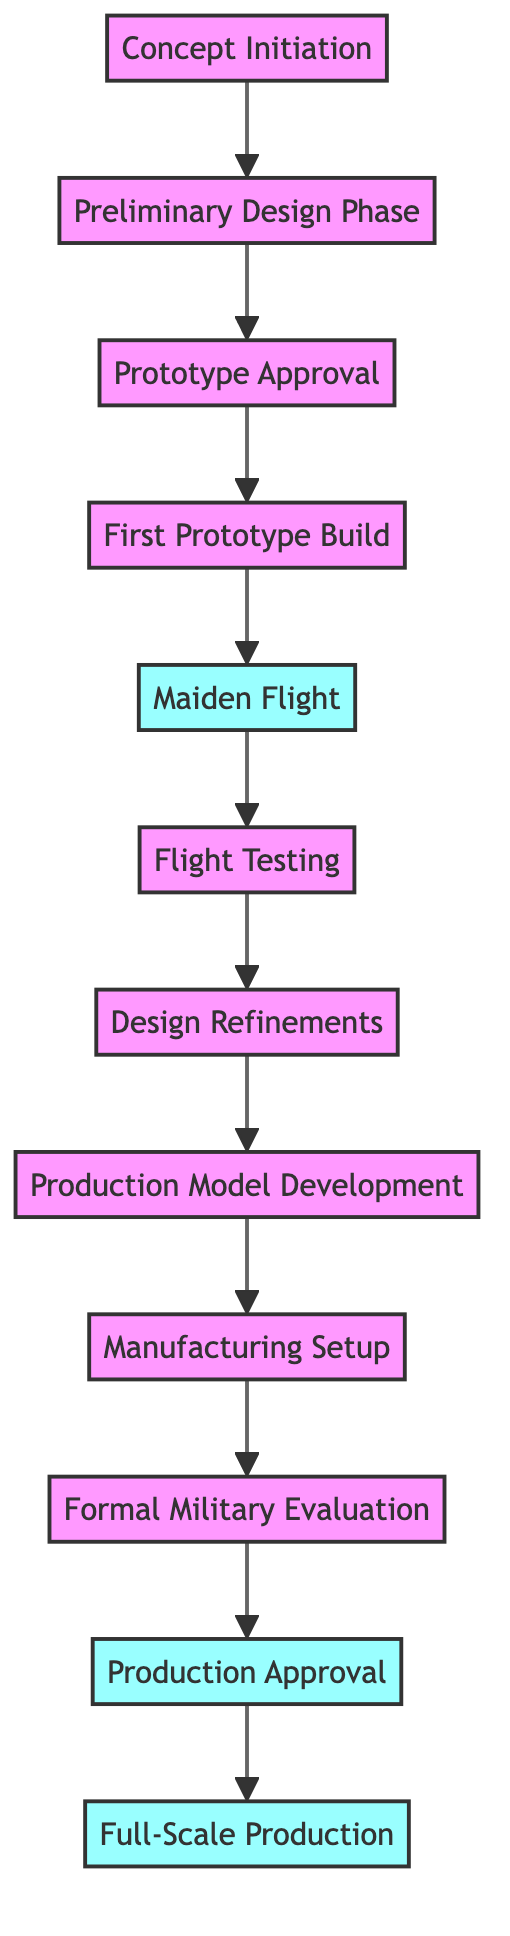What is the first step in the development timeline of the T-50 aircraft? The first step in the timeline is labeled "Concept Initiation," which is where the initial vision and design proposals are established.
Answer: Concept Initiation How many total nodes are there in the diagram? By counting the nodes listed, there are twelve specific stages in the development of the T-50 aircraft from concept to production.
Answer: 12 Which node comes after the "Maiden Flight"? The node that follows "Maiden Flight" is "Flight Testing," indicating that after the first flight, extensive testing begins for the aircraft.
Answer: Flight Testing What is the last activity before "Full-Scale Production"? Before reaching "Full-Scale Production," the preceding activity is "Production Approval," where formal approval for mass production is granted.
Answer: Production Approval Is "Design Refinements" a milestone in the timeline? "Design Refinements" is not designated as a milestone in the diagram, as only “Maiden Flight,” “Production Approval,” and “Full-Scale Production” are marked as such.
Answer: No How many edges connect the nodes in the diagram? The edges connecting the nodes represent the steps or transitions between stages, and there are eleven edges present in the diagram, indicating the flow from concept to production.
Answer: 11 What are the two activities that directly precede "Production Model Development"? The two activities that occur just before "Production Model Development" are "Design Refinements" and "Flight Testing," showcasing the process of iterating on the design after rigorous testing.
Answer: Design Refinements, Flight Testing Which activity is the first milestone in the development timeline? The first milestone in the timeline is "Maiden Flight," which represents a significant achievement in the aircraft's development, marking the completion of the first prototype flight.
Answer: Maiden Flight What node represents the transition from development to manufacturing? The node that signifies this transition from development to manufacturing is "Manufacturing Setup," which involves preparing facilities for production after model development.
Answer: Manufacturing Setup 